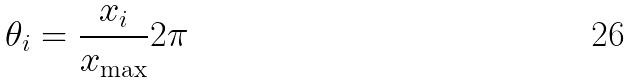<formula> <loc_0><loc_0><loc_500><loc_500>\theta _ { i } = \frac { x _ { i } } { x _ { \max } } 2 \pi</formula> 